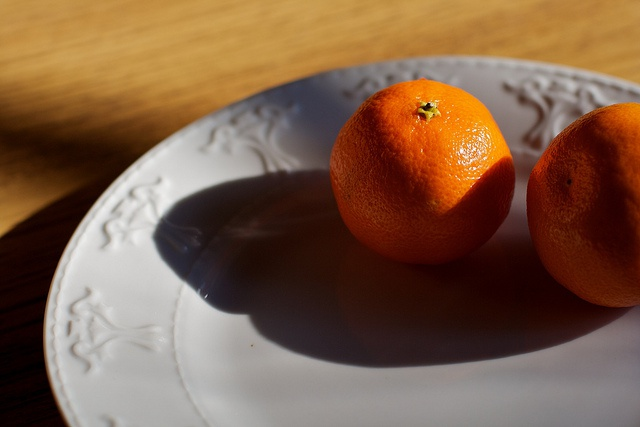Describe the objects in this image and their specific colors. I can see dining table in tan, black, olive, and orange tones, orange in tan, maroon, red, and orange tones, and orange in tan, maroon, and red tones in this image. 